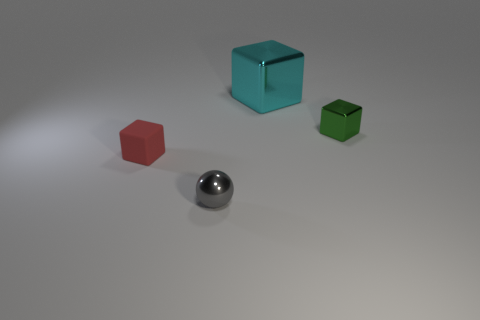How many large things are either gray cubes or cyan metal blocks?
Offer a terse response. 1. There is a small object that is behind the small rubber thing; what shape is it?
Your response must be concise. Cube. Is there another metallic sphere that has the same color as the sphere?
Keep it short and to the point. No. Does the sphere to the left of the cyan metal object have the same size as the metallic cube in front of the cyan object?
Offer a very short reply. Yes. Is the number of small metallic balls that are on the left side of the small red rubber object greater than the number of red matte things that are on the right side of the small gray thing?
Offer a very short reply. No. Are there any red cubes made of the same material as the green block?
Make the answer very short. No. Is the matte block the same color as the shiny sphere?
Keep it short and to the point. No. What is the material of the block that is both behind the small matte object and on the left side of the small green object?
Provide a short and direct response. Metal. The matte cube is what color?
Ensure brevity in your answer.  Red. How many red matte objects are the same shape as the big cyan metallic object?
Your answer should be very brief. 1. 